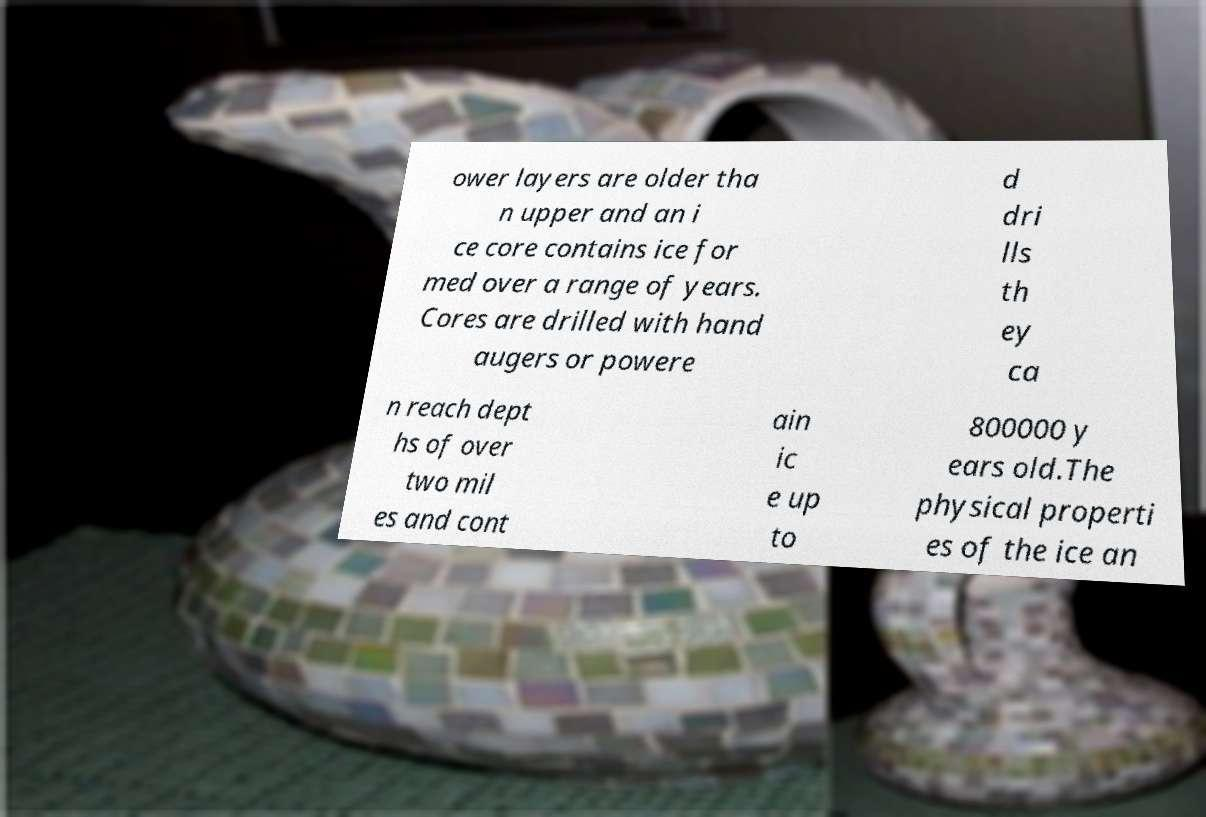Could you assist in decoding the text presented in this image and type it out clearly? ower layers are older tha n upper and an i ce core contains ice for med over a range of years. Cores are drilled with hand augers or powere d dri lls th ey ca n reach dept hs of over two mil es and cont ain ic e up to 800000 y ears old.The physical properti es of the ice an 